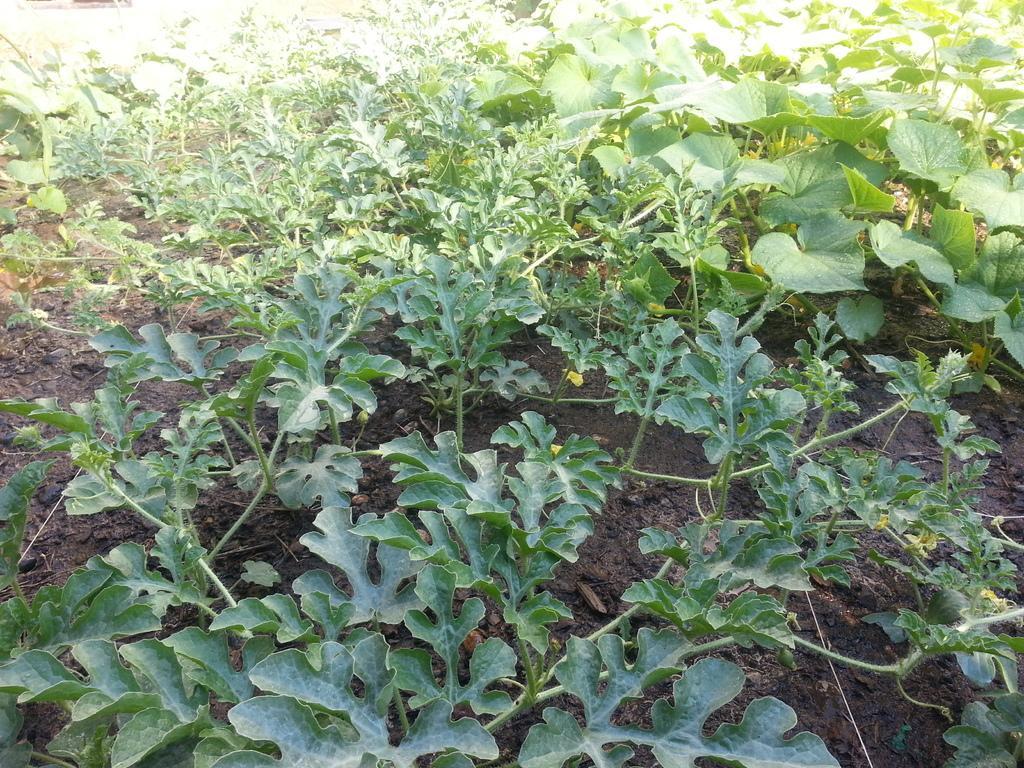Could you give a brief overview of what you see in this image? In this image, I can see the plants with leaves, which are green in color. This is the mud. 